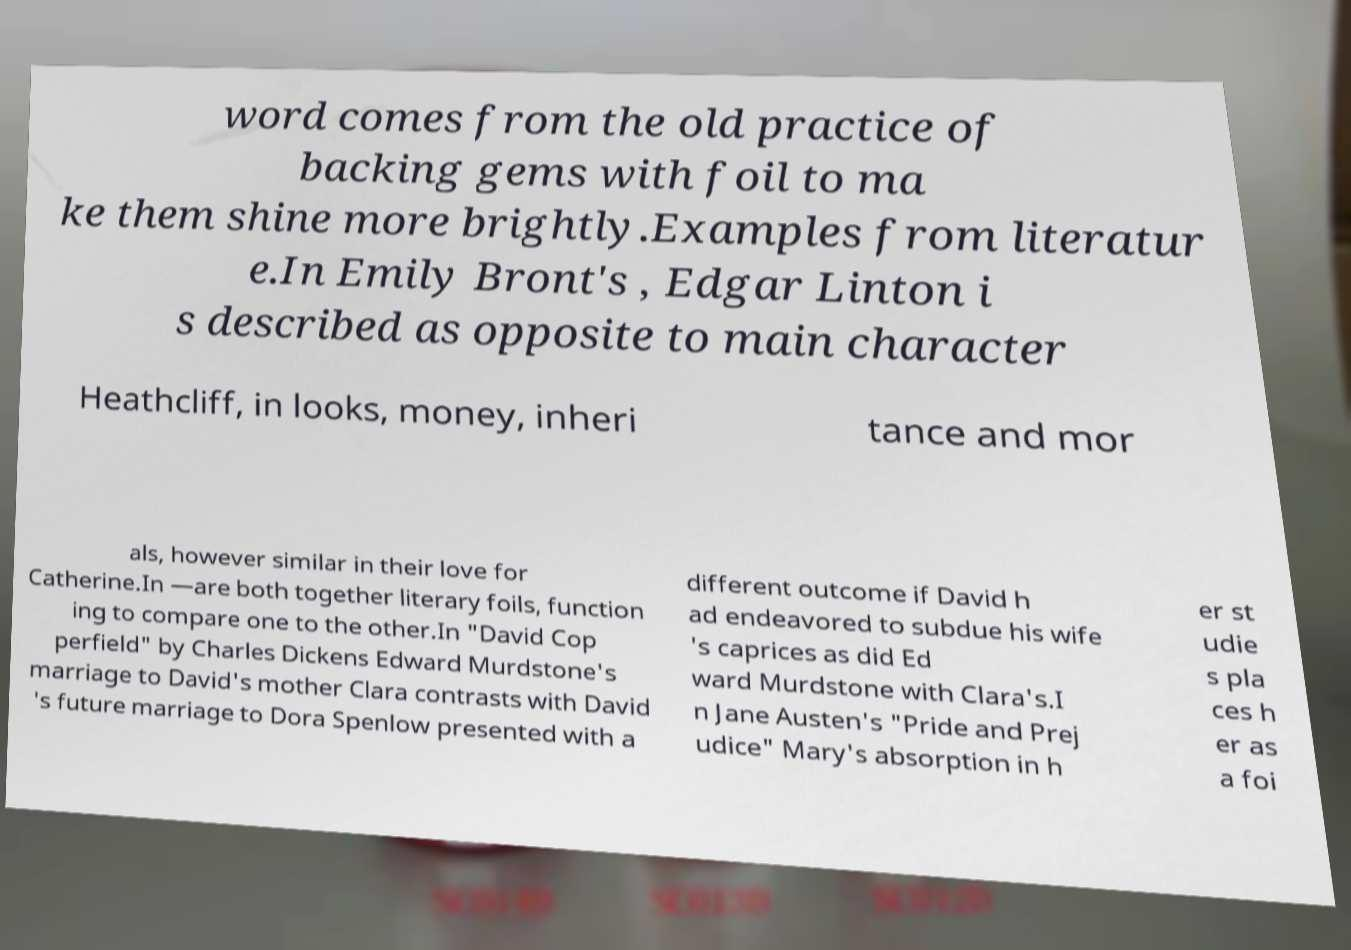Please read and relay the text visible in this image. What does it say? word comes from the old practice of backing gems with foil to ma ke them shine more brightly.Examples from literatur e.In Emily Bront's , Edgar Linton i s described as opposite to main character Heathcliff, in looks, money, inheri tance and mor als, however similar in their love for Catherine.In —are both together literary foils, function ing to compare one to the other.In "David Cop perfield" by Charles Dickens Edward Murdstone's marriage to David's mother Clara contrasts with David 's future marriage to Dora Spenlow presented with a different outcome if David h ad endeavored to subdue his wife 's caprices as did Ed ward Murdstone with Clara's.I n Jane Austen's "Pride and Prej udice" Mary's absorption in h er st udie s pla ces h er as a foi 